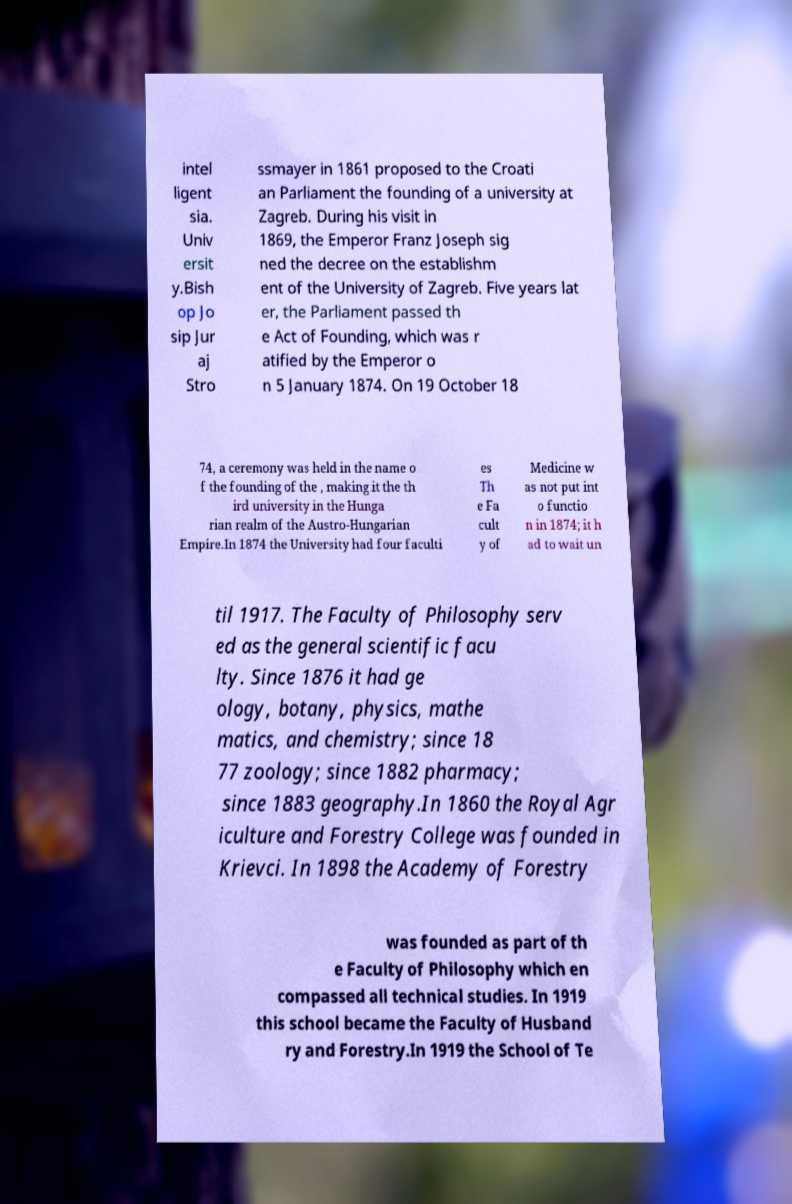Please read and relay the text visible in this image. What does it say? intel ligent sia. Univ ersit y.Bish op Jo sip Jur aj Stro ssmayer in 1861 proposed to the Croati an Parliament the founding of a university at Zagreb. During his visit in 1869, the Emperor Franz Joseph sig ned the decree on the establishm ent of the University of Zagreb. Five years lat er, the Parliament passed th e Act of Founding, which was r atified by the Emperor o n 5 January 1874. On 19 October 18 74, a ceremony was held in the name o f the founding of the , making it the th ird university in the Hunga rian realm of the Austro-Hungarian Empire.In 1874 the University had four faculti es Th e Fa cult y of Medicine w as not put int o functio n in 1874; it h ad to wait un til 1917. The Faculty of Philosophy serv ed as the general scientific facu lty. Since 1876 it had ge ology, botany, physics, mathe matics, and chemistry; since 18 77 zoology; since 1882 pharmacy; since 1883 geography.In 1860 the Royal Agr iculture and Forestry College was founded in Krievci. In 1898 the Academy of Forestry was founded as part of th e Faculty of Philosophy which en compassed all technical studies. In 1919 this school became the Faculty of Husband ry and Forestry.In 1919 the School of Te 